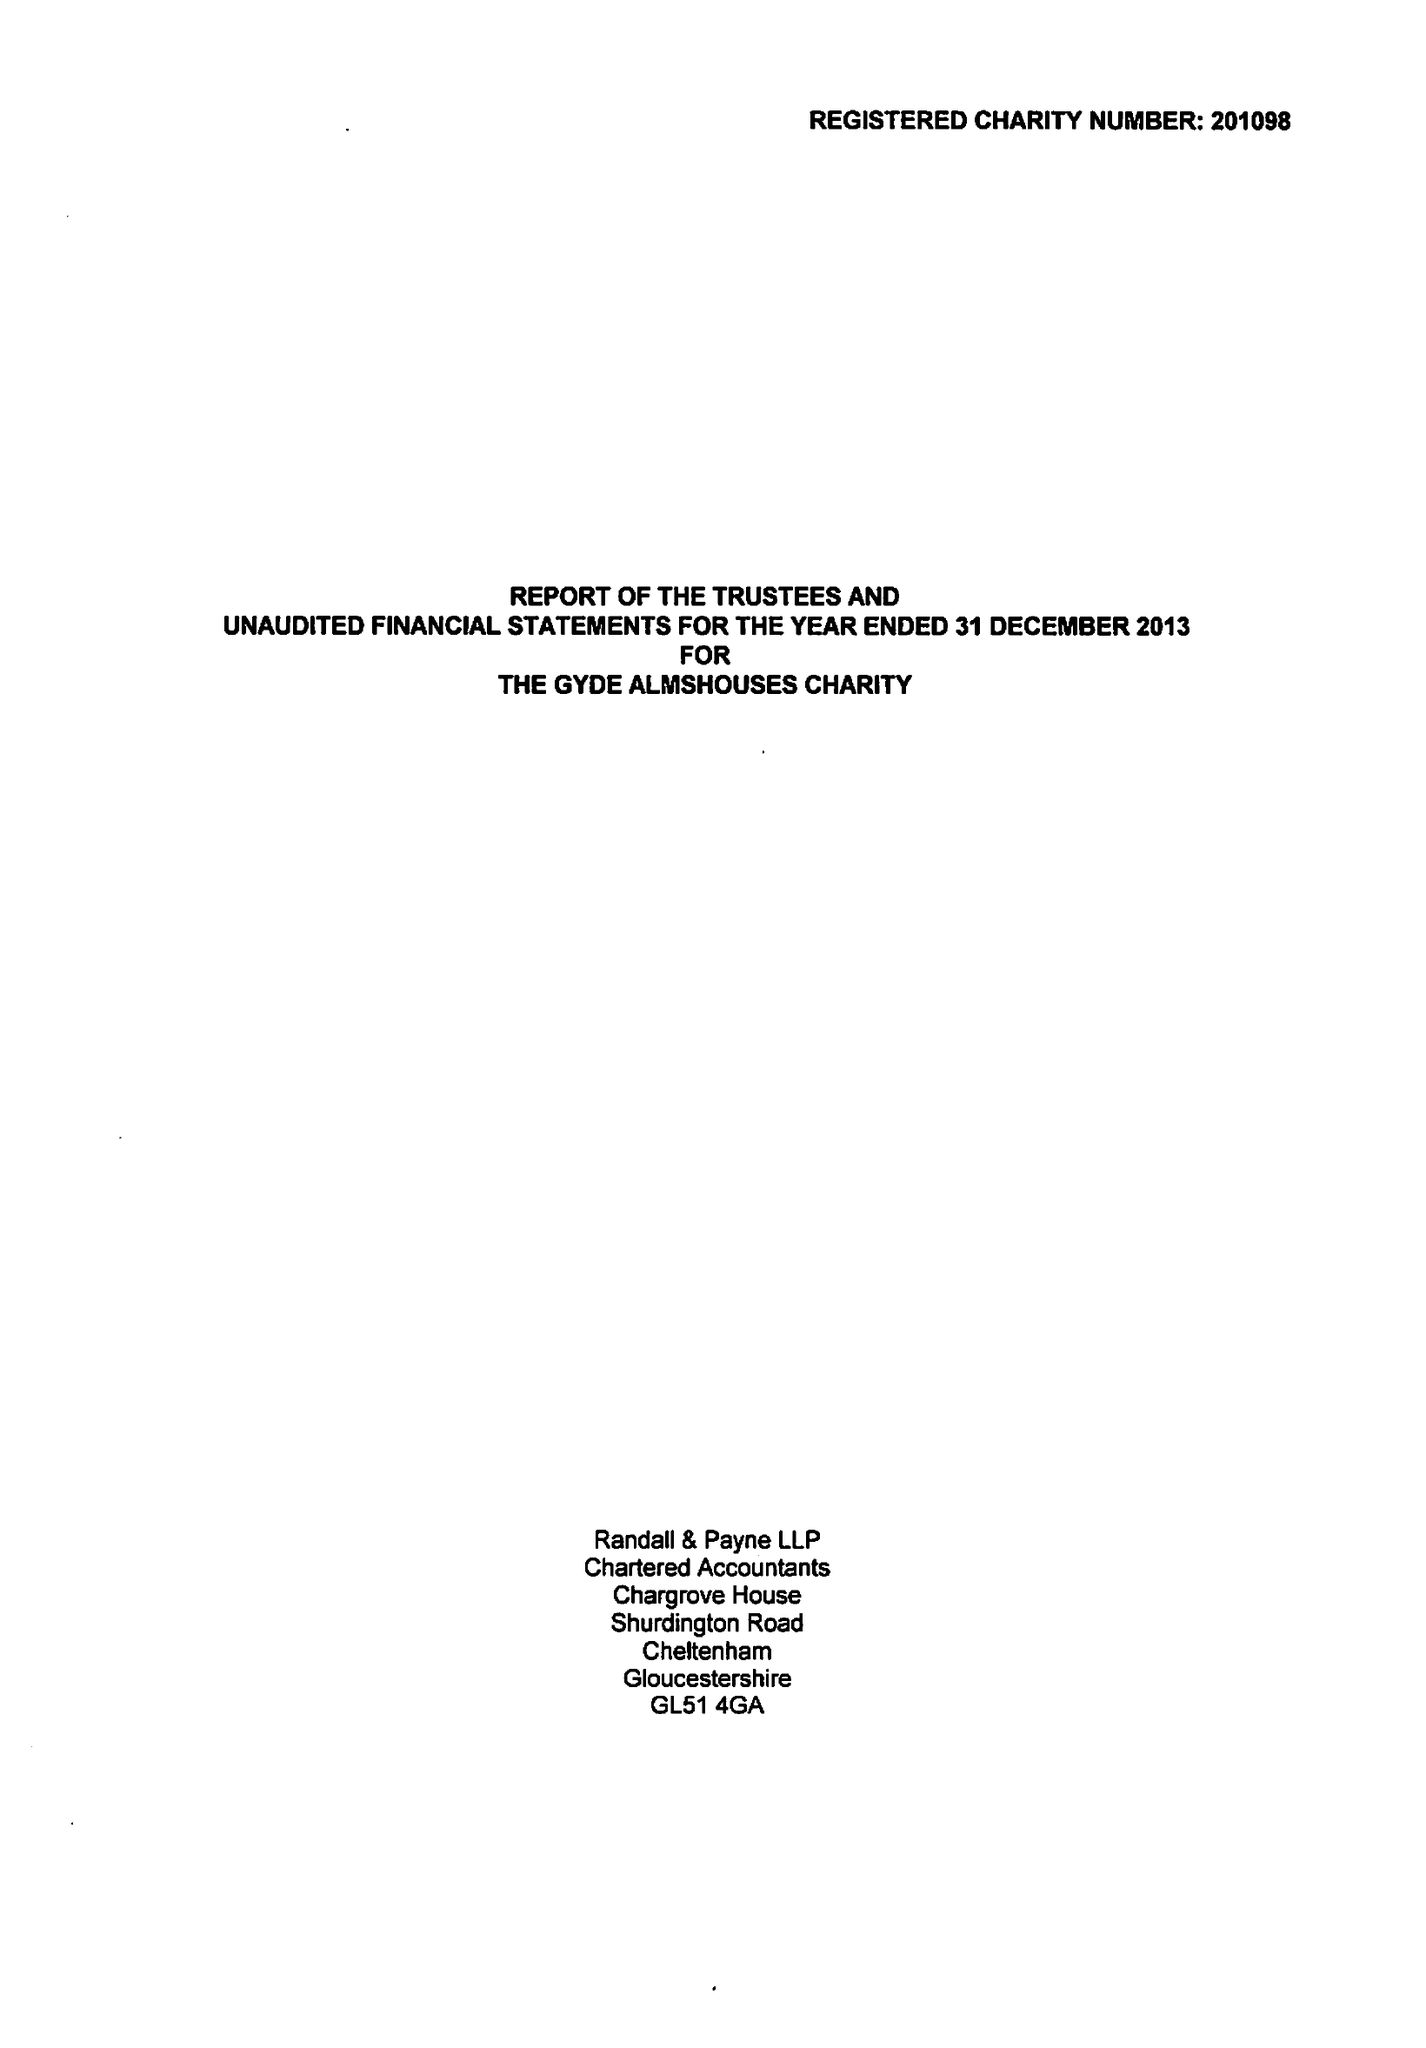What is the value for the charity_name?
Answer the question using a single word or phrase. The Gyde Almshouses Charity 